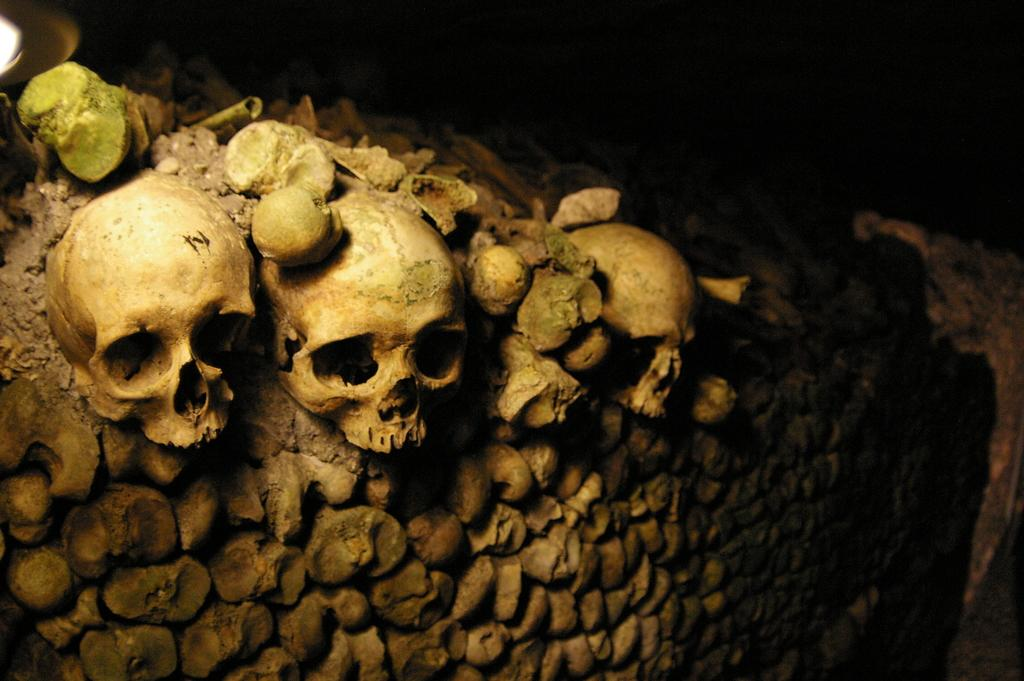What objects can be seen in the image? There are skulls and pieces of lemons in the image. What is visible in the background of the image? There is a wall in the background of the image. How would you describe the lighting in the image? The background of the image is dark. What type of curtain can be seen hanging from the wall in the image? There is no curtain present in the image; only skulls, pieces of lemons, and a wall are visible. 